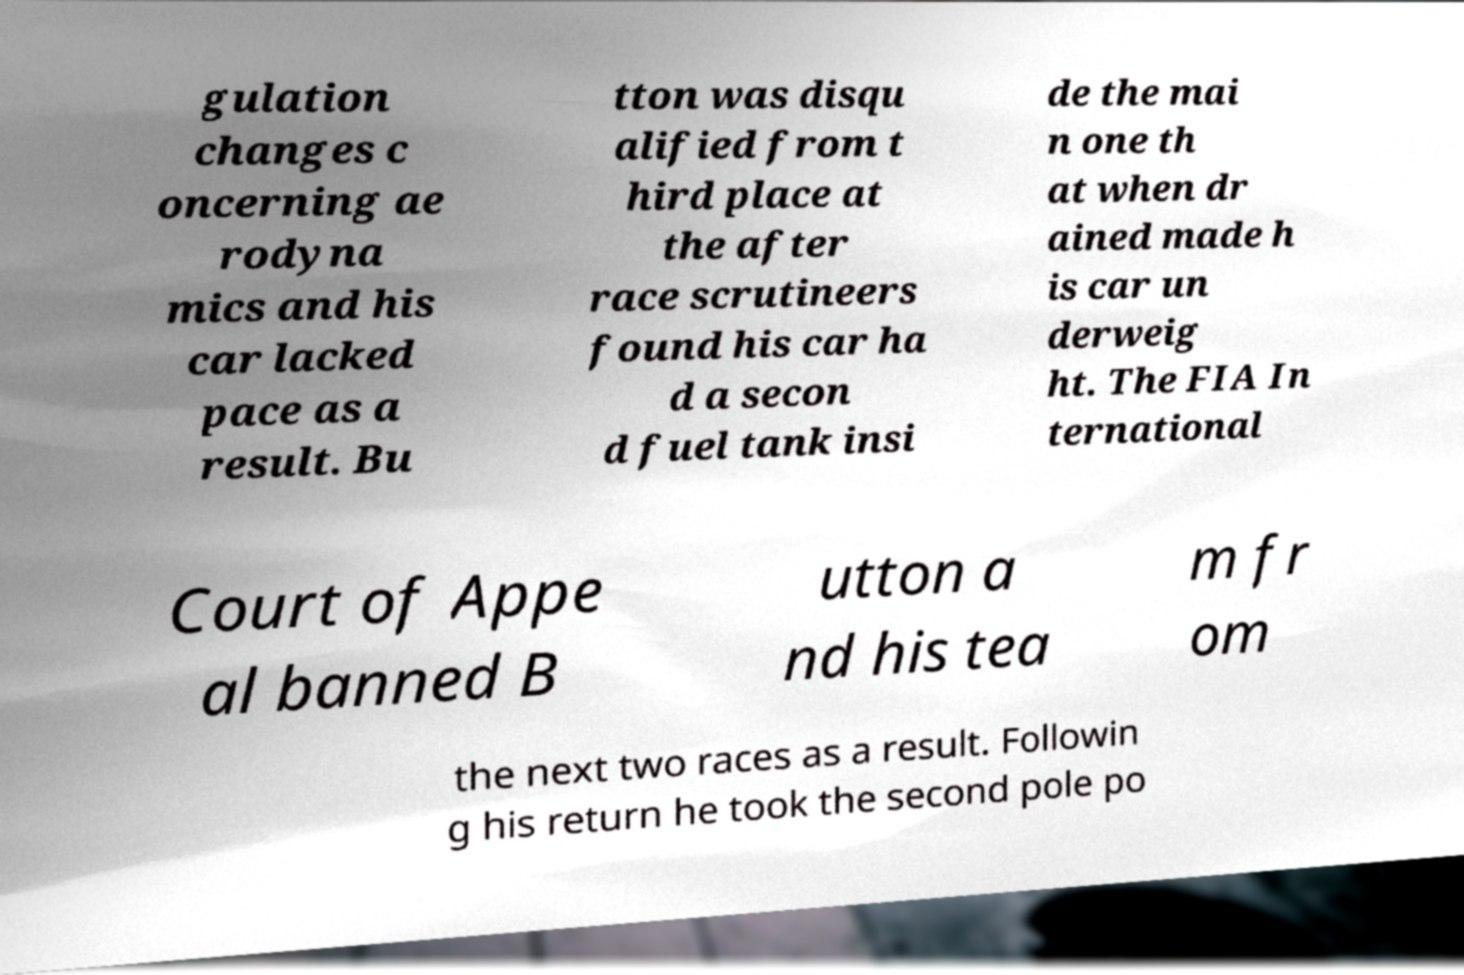Could you extract and type out the text from this image? gulation changes c oncerning ae rodyna mics and his car lacked pace as a result. Bu tton was disqu alified from t hird place at the after race scrutineers found his car ha d a secon d fuel tank insi de the mai n one th at when dr ained made h is car un derweig ht. The FIA In ternational Court of Appe al banned B utton a nd his tea m fr om the next two races as a result. Followin g his return he took the second pole po 